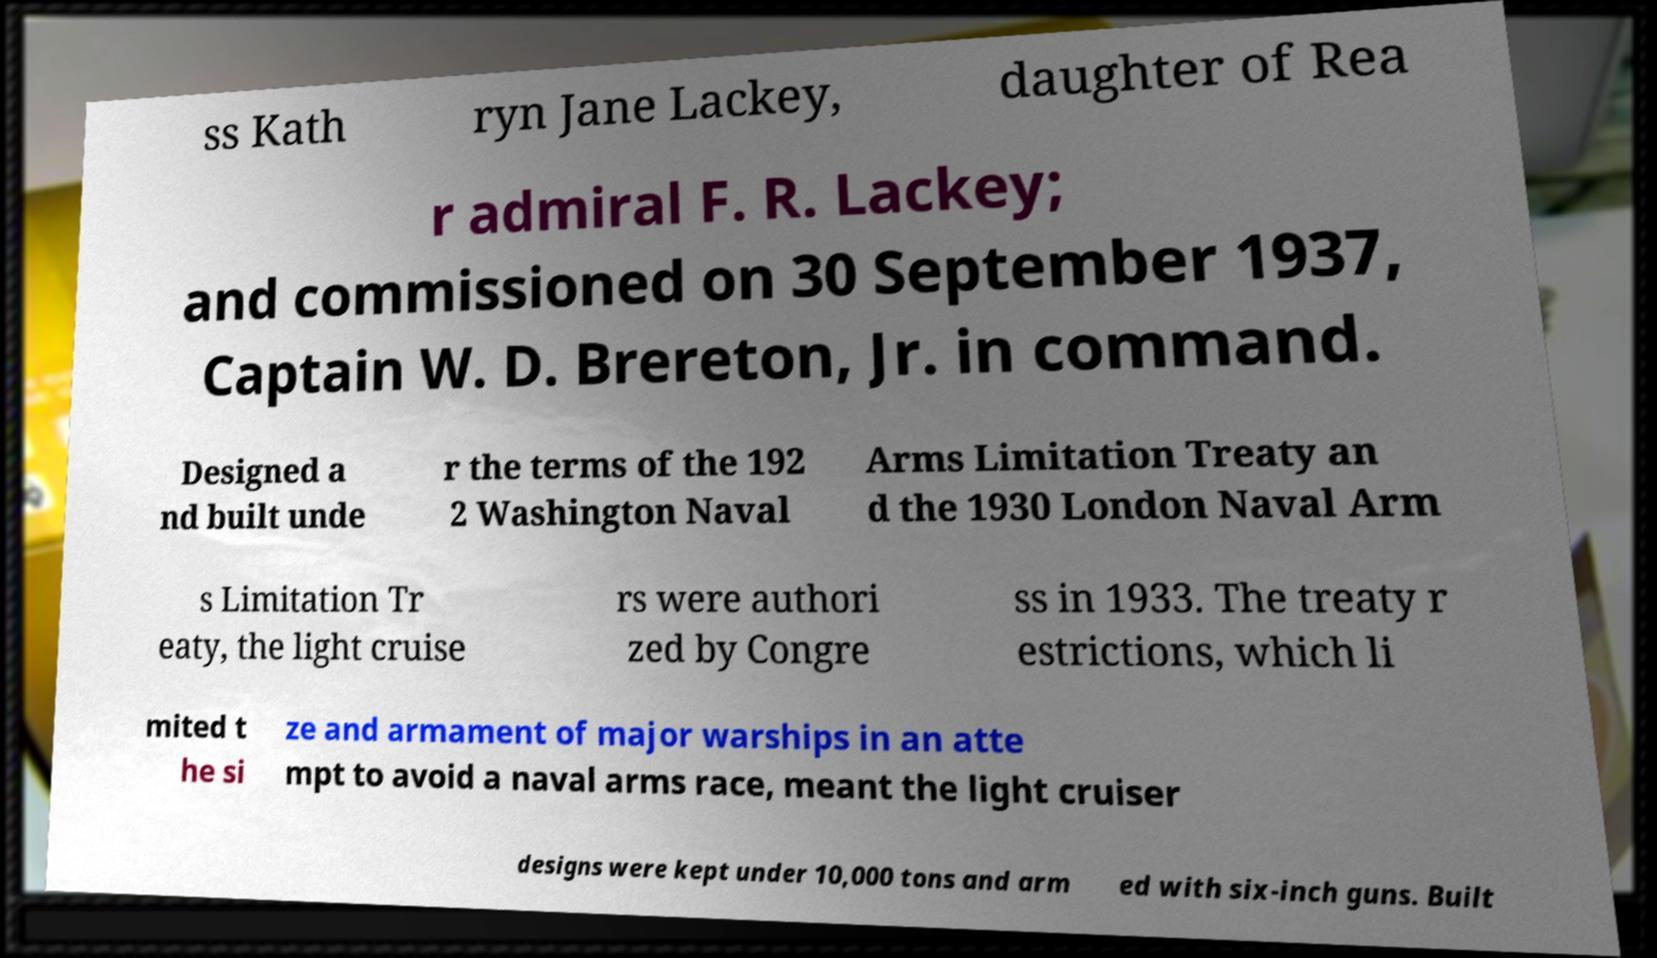Could you extract and type out the text from this image? ss Kath ryn Jane Lackey, daughter of Rea r admiral F. R. Lackey; and commissioned on 30 September 1937, Captain W. D. Brereton, Jr. in command. Designed a nd built unde r the terms of the 192 2 Washington Naval Arms Limitation Treaty an d the 1930 London Naval Arm s Limitation Tr eaty, the light cruise rs were authori zed by Congre ss in 1933. The treaty r estrictions, which li mited t he si ze and armament of major warships in an atte mpt to avoid a naval arms race, meant the light cruiser designs were kept under 10,000 tons and arm ed with six-inch guns. Built 